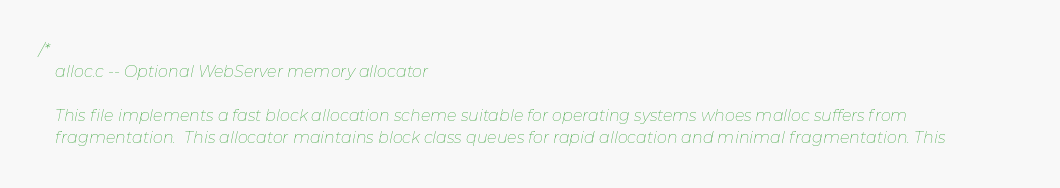Convert code to text. <code><loc_0><loc_0><loc_500><loc_500><_C_>/*
    alloc.c -- Optional WebServer memory allocator

    This file implements a fast block allocation scheme suitable for operating systems whoes malloc suffers from
    fragmentation.  This allocator maintains block class queues for rapid allocation and minimal fragmentation. This</code> 